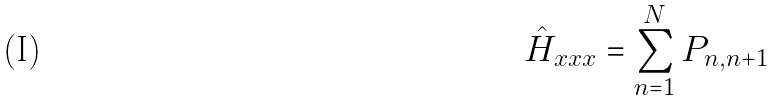<formula> <loc_0><loc_0><loc_500><loc_500>\hat { H } _ { x x x } = \sum _ { n = 1 } ^ { N } P _ { n , n + 1 }</formula> 